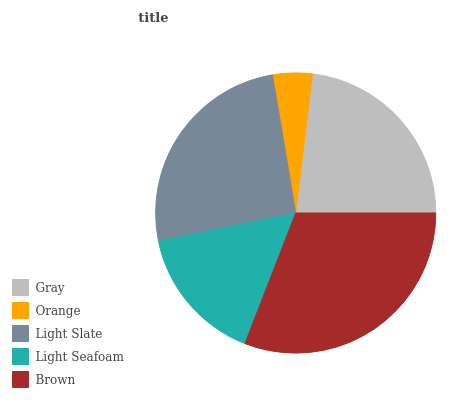Is Orange the minimum?
Answer yes or no. Yes. Is Brown the maximum?
Answer yes or no. Yes. Is Light Slate the minimum?
Answer yes or no. No. Is Light Slate the maximum?
Answer yes or no. No. Is Light Slate greater than Orange?
Answer yes or no. Yes. Is Orange less than Light Slate?
Answer yes or no. Yes. Is Orange greater than Light Slate?
Answer yes or no. No. Is Light Slate less than Orange?
Answer yes or no. No. Is Gray the high median?
Answer yes or no. Yes. Is Gray the low median?
Answer yes or no. Yes. Is Brown the high median?
Answer yes or no. No. Is Light Slate the low median?
Answer yes or no. No. 